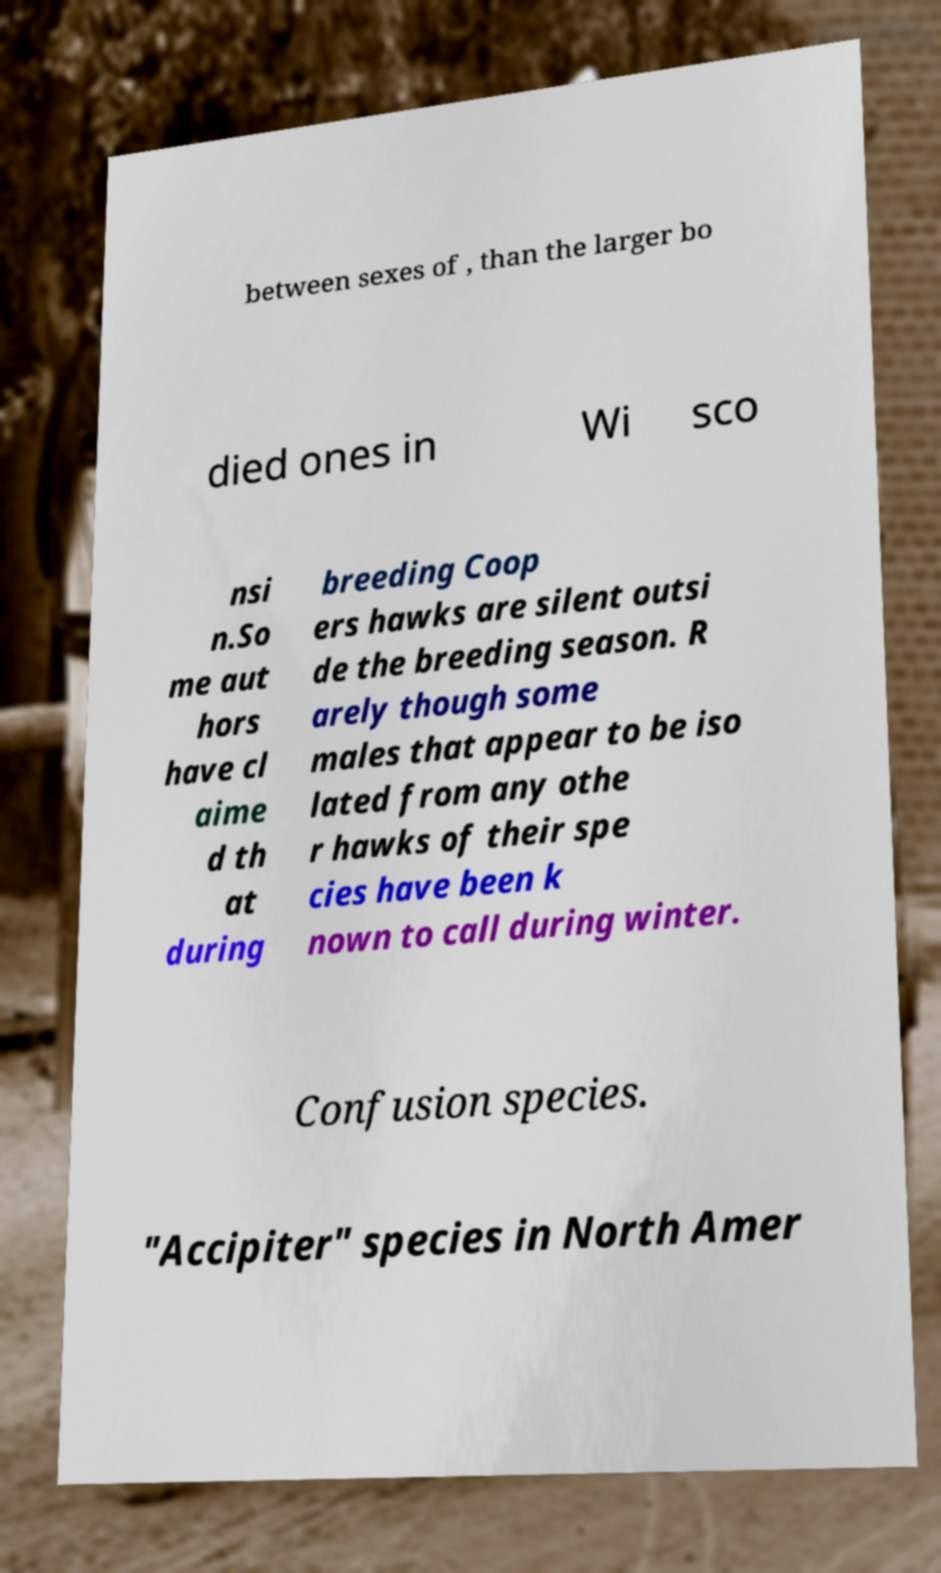Please read and relay the text visible in this image. What does it say? between sexes of , than the larger bo died ones in Wi sco nsi n.So me aut hors have cl aime d th at during breeding Coop ers hawks are silent outsi de the breeding season. R arely though some males that appear to be iso lated from any othe r hawks of their spe cies have been k nown to call during winter. Confusion species. "Accipiter" species in North Amer 